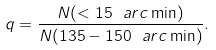Convert formula to latex. <formula><loc_0><loc_0><loc_500><loc_500>q = \frac { N ( < 1 5 \ a r c \min ) } { N ( 1 3 5 - 1 5 0 \ a r c \min ) } .</formula> 